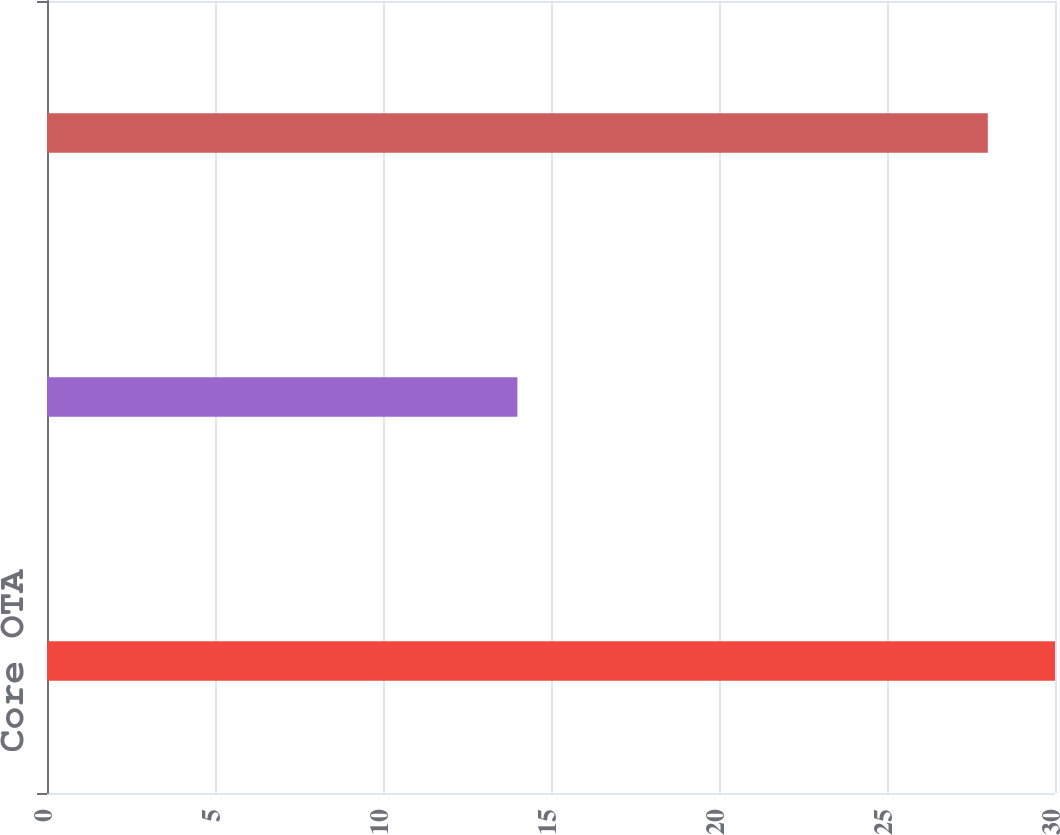Convert chart to OTSL. <chart><loc_0><loc_0><loc_500><loc_500><bar_chart><fcel>Core OTA<fcel>Egencia<fcel>Total gross bookings<nl><fcel>30<fcel>14<fcel>28<nl></chart> 